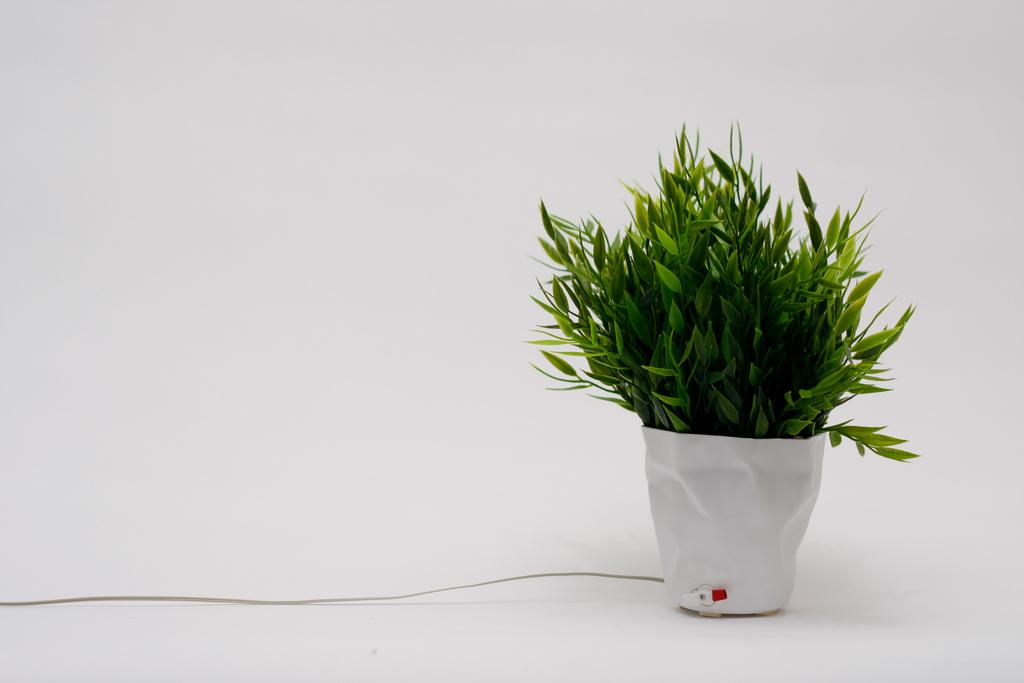What type of living organism is present in the image? There is a plant in the image. Where is the plant located? The plant is in a flower pot. What color is the flower pot? The flower pot is white. What type of lunch is the plant eating in the image? There is no lunch present in the image, as plants do not eat lunch. 